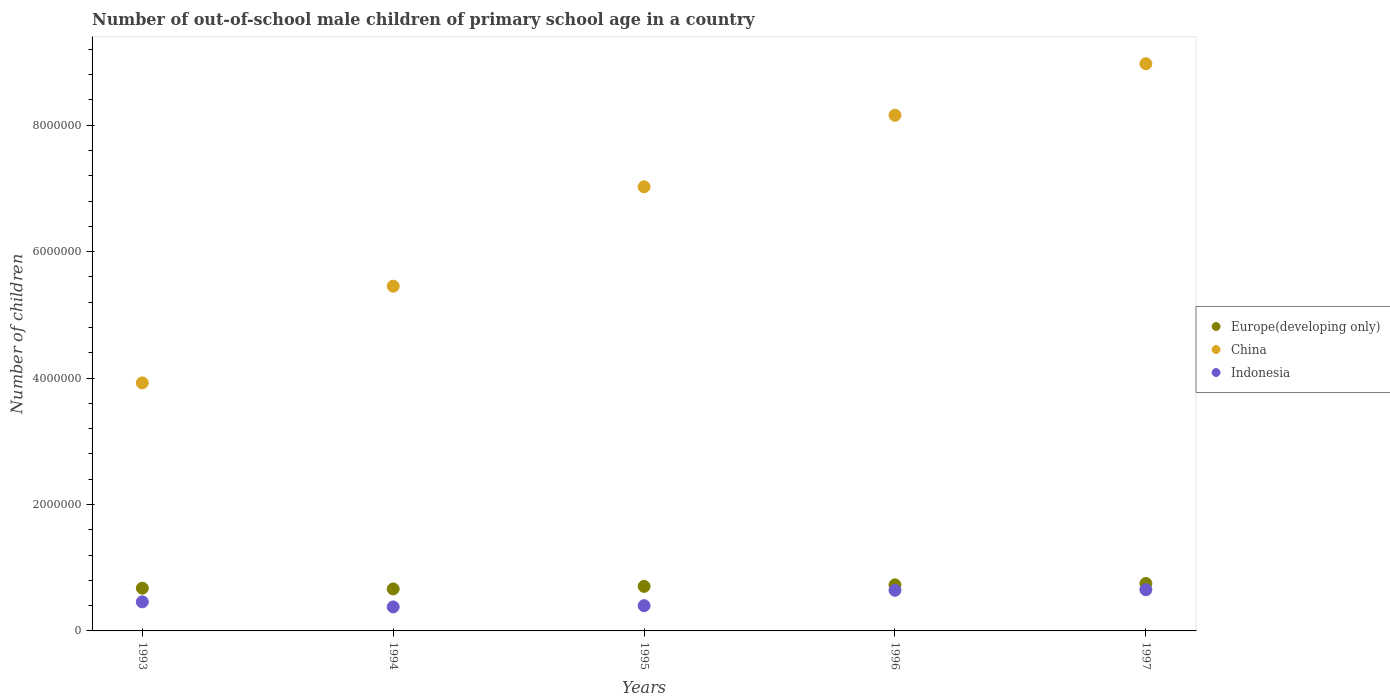How many different coloured dotlines are there?
Your response must be concise. 3. What is the number of out-of-school male children in Indonesia in 1996?
Your response must be concise. 6.43e+05. Across all years, what is the maximum number of out-of-school male children in Europe(developing only)?
Provide a succinct answer. 7.51e+05. Across all years, what is the minimum number of out-of-school male children in Indonesia?
Your answer should be very brief. 3.79e+05. In which year was the number of out-of-school male children in China minimum?
Your answer should be compact. 1993. What is the total number of out-of-school male children in Europe(developing only) in the graph?
Keep it short and to the point. 3.52e+06. What is the difference between the number of out-of-school male children in Europe(developing only) in 1993 and that in 1997?
Provide a short and direct response. -7.45e+04. What is the difference between the number of out-of-school male children in Indonesia in 1995 and the number of out-of-school male children in China in 1997?
Your answer should be very brief. -8.57e+06. What is the average number of out-of-school male children in China per year?
Keep it short and to the point. 6.71e+06. In the year 1997, what is the difference between the number of out-of-school male children in Indonesia and number of out-of-school male children in China?
Give a very brief answer. -8.32e+06. What is the ratio of the number of out-of-school male children in China in 1993 to that in 1997?
Give a very brief answer. 0.44. Is the difference between the number of out-of-school male children in Indonesia in 1995 and 1997 greater than the difference between the number of out-of-school male children in China in 1995 and 1997?
Offer a very short reply. Yes. What is the difference between the highest and the second highest number of out-of-school male children in China?
Offer a very short reply. 8.15e+05. What is the difference between the highest and the lowest number of out-of-school male children in Europe(developing only)?
Give a very brief answer. 8.62e+04. Is the sum of the number of out-of-school male children in Indonesia in 1993 and 1997 greater than the maximum number of out-of-school male children in China across all years?
Your answer should be very brief. No. Is it the case that in every year, the sum of the number of out-of-school male children in Europe(developing only) and number of out-of-school male children in Indonesia  is greater than the number of out-of-school male children in China?
Provide a short and direct response. No. How many years are there in the graph?
Offer a terse response. 5. Are the values on the major ticks of Y-axis written in scientific E-notation?
Ensure brevity in your answer.  No. How many legend labels are there?
Your response must be concise. 3. What is the title of the graph?
Ensure brevity in your answer.  Number of out-of-school male children of primary school age in a country. What is the label or title of the Y-axis?
Provide a succinct answer. Number of children. What is the Number of children of Europe(developing only) in 1993?
Your response must be concise. 6.76e+05. What is the Number of children of China in 1993?
Offer a terse response. 3.92e+06. What is the Number of children in Indonesia in 1993?
Offer a very short reply. 4.60e+05. What is the Number of children of Europe(developing only) in 1994?
Provide a short and direct response. 6.64e+05. What is the Number of children in China in 1994?
Provide a succinct answer. 5.45e+06. What is the Number of children of Indonesia in 1994?
Your answer should be very brief. 3.79e+05. What is the Number of children of Europe(developing only) in 1995?
Give a very brief answer. 7.05e+05. What is the Number of children in China in 1995?
Give a very brief answer. 7.03e+06. What is the Number of children of Indonesia in 1995?
Make the answer very short. 4.00e+05. What is the Number of children of Europe(developing only) in 1996?
Provide a short and direct response. 7.29e+05. What is the Number of children in China in 1996?
Your answer should be very brief. 8.16e+06. What is the Number of children of Indonesia in 1996?
Ensure brevity in your answer.  6.43e+05. What is the Number of children in Europe(developing only) in 1997?
Your answer should be compact. 7.51e+05. What is the Number of children in China in 1997?
Provide a succinct answer. 8.97e+06. What is the Number of children in Indonesia in 1997?
Ensure brevity in your answer.  6.51e+05. Across all years, what is the maximum Number of children of Europe(developing only)?
Your answer should be very brief. 7.51e+05. Across all years, what is the maximum Number of children in China?
Ensure brevity in your answer.  8.97e+06. Across all years, what is the maximum Number of children of Indonesia?
Provide a short and direct response. 6.51e+05. Across all years, what is the minimum Number of children in Europe(developing only)?
Your answer should be compact. 6.64e+05. Across all years, what is the minimum Number of children of China?
Ensure brevity in your answer.  3.92e+06. Across all years, what is the minimum Number of children of Indonesia?
Your answer should be very brief. 3.79e+05. What is the total Number of children in Europe(developing only) in the graph?
Keep it short and to the point. 3.52e+06. What is the total Number of children of China in the graph?
Your answer should be very brief. 3.35e+07. What is the total Number of children of Indonesia in the graph?
Ensure brevity in your answer.  2.53e+06. What is the difference between the Number of children in Europe(developing only) in 1993 and that in 1994?
Make the answer very short. 1.17e+04. What is the difference between the Number of children in China in 1993 and that in 1994?
Provide a succinct answer. -1.53e+06. What is the difference between the Number of children in Indonesia in 1993 and that in 1994?
Give a very brief answer. 8.03e+04. What is the difference between the Number of children in Europe(developing only) in 1993 and that in 1995?
Ensure brevity in your answer.  -2.86e+04. What is the difference between the Number of children in China in 1993 and that in 1995?
Provide a succinct answer. -3.10e+06. What is the difference between the Number of children of Indonesia in 1993 and that in 1995?
Give a very brief answer. 6.02e+04. What is the difference between the Number of children in Europe(developing only) in 1993 and that in 1996?
Provide a succinct answer. -5.28e+04. What is the difference between the Number of children of China in 1993 and that in 1996?
Your answer should be very brief. -4.23e+06. What is the difference between the Number of children of Indonesia in 1993 and that in 1996?
Provide a short and direct response. -1.83e+05. What is the difference between the Number of children of Europe(developing only) in 1993 and that in 1997?
Your answer should be compact. -7.45e+04. What is the difference between the Number of children of China in 1993 and that in 1997?
Offer a very short reply. -5.05e+06. What is the difference between the Number of children of Indonesia in 1993 and that in 1997?
Your response must be concise. -1.92e+05. What is the difference between the Number of children of Europe(developing only) in 1994 and that in 1995?
Your answer should be compact. -4.03e+04. What is the difference between the Number of children of China in 1994 and that in 1995?
Offer a terse response. -1.57e+06. What is the difference between the Number of children in Indonesia in 1994 and that in 1995?
Provide a succinct answer. -2.02e+04. What is the difference between the Number of children in Europe(developing only) in 1994 and that in 1996?
Offer a terse response. -6.45e+04. What is the difference between the Number of children in China in 1994 and that in 1996?
Keep it short and to the point. -2.70e+06. What is the difference between the Number of children of Indonesia in 1994 and that in 1996?
Ensure brevity in your answer.  -2.64e+05. What is the difference between the Number of children in Europe(developing only) in 1994 and that in 1997?
Offer a very short reply. -8.62e+04. What is the difference between the Number of children of China in 1994 and that in 1997?
Offer a terse response. -3.52e+06. What is the difference between the Number of children in Indonesia in 1994 and that in 1997?
Keep it short and to the point. -2.72e+05. What is the difference between the Number of children in Europe(developing only) in 1995 and that in 1996?
Your answer should be compact. -2.42e+04. What is the difference between the Number of children in China in 1995 and that in 1996?
Your answer should be very brief. -1.13e+06. What is the difference between the Number of children of Indonesia in 1995 and that in 1996?
Offer a terse response. -2.43e+05. What is the difference between the Number of children of Europe(developing only) in 1995 and that in 1997?
Ensure brevity in your answer.  -4.59e+04. What is the difference between the Number of children in China in 1995 and that in 1997?
Provide a short and direct response. -1.95e+06. What is the difference between the Number of children of Indonesia in 1995 and that in 1997?
Offer a very short reply. -2.52e+05. What is the difference between the Number of children of Europe(developing only) in 1996 and that in 1997?
Keep it short and to the point. -2.17e+04. What is the difference between the Number of children of China in 1996 and that in 1997?
Offer a very short reply. -8.15e+05. What is the difference between the Number of children of Indonesia in 1996 and that in 1997?
Your response must be concise. -8521. What is the difference between the Number of children of Europe(developing only) in 1993 and the Number of children of China in 1994?
Your answer should be compact. -4.78e+06. What is the difference between the Number of children of Europe(developing only) in 1993 and the Number of children of Indonesia in 1994?
Keep it short and to the point. 2.97e+05. What is the difference between the Number of children of China in 1993 and the Number of children of Indonesia in 1994?
Offer a terse response. 3.54e+06. What is the difference between the Number of children in Europe(developing only) in 1993 and the Number of children in China in 1995?
Keep it short and to the point. -6.35e+06. What is the difference between the Number of children of Europe(developing only) in 1993 and the Number of children of Indonesia in 1995?
Keep it short and to the point. 2.76e+05. What is the difference between the Number of children in China in 1993 and the Number of children in Indonesia in 1995?
Your response must be concise. 3.52e+06. What is the difference between the Number of children of Europe(developing only) in 1993 and the Number of children of China in 1996?
Make the answer very short. -7.48e+06. What is the difference between the Number of children of Europe(developing only) in 1993 and the Number of children of Indonesia in 1996?
Offer a terse response. 3.31e+04. What is the difference between the Number of children in China in 1993 and the Number of children in Indonesia in 1996?
Make the answer very short. 3.28e+06. What is the difference between the Number of children of Europe(developing only) in 1993 and the Number of children of China in 1997?
Keep it short and to the point. -8.30e+06. What is the difference between the Number of children in Europe(developing only) in 1993 and the Number of children in Indonesia in 1997?
Provide a short and direct response. 2.46e+04. What is the difference between the Number of children of China in 1993 and the Number of children of Indonesia in 1997?
Make the answer very short. 3.27e+06. What is the difference between the Number of children in Europe(developing only) in 1994 and the Number of children in China in 1995?
Your answer should be compact. -6.36e+06. What is the difference between the Number of children of Europe(developing only) in 1994 and the Number of children of Indonesia in 1995?
Your response must be concise. 2.65e+05. What is the difference between the Number of children of China in 1994 and the Number of children of Indonesia in 1995?
Offer a terse response. 5.05e+06. What is the difference between the Number of children in Europe(developing only) in 1994 and the Number of children in China in 1996?
Provide a short and direct response. -7.49e+06. What is the difference between the Number of children of Europe(developing only) in 1994 and the Number of children of Indonesia in 1996?
Your answer should be compact. 2.13e+04. What is the difference between the Number of children in China in 1994 and the Number of children in Indonesia in 1996?
Provide a short and direct response. 4.81e+06. What is the difference between the Number of children in Europe(developing only) in 1994 and the Number of children in China in 1997?
Offer a very short reply. -8.31e+06. What is the difference between the Number of children in Europe(developing only) in 1994 and the Number of children in Indonesia in 1997?
Give a very brief answer. 1.28e+04. What is the difference between the Number of children in China in 1994 and the Number of children in Indonesia in 1997?
Make the answer very short. 4.80e+06. What is the difference between the Number of children of Europe(developing only) in 1995 and the Number of children of China in 1996?
Your answer should be compact. -7.45e+06. What is the difference between the Number of children of Europe(developing only) in 1995 and the Number of children of Indonesia in 1996?
Provide a short and direct response. 6.17e+04. What is the difference between the Number of children in China in 1995 and the Number of children in Indonesia in 1996?
Offer a terse response. 6.38e+06. What is the difference between the Number of children in Europe(developing only) in 1995 and the Number of children in China in 1997?
Your answer should be very brief. -8.27e+06. What is the difference between the Number of children of Europe(developing only) in 1995 and the Number of children of Indonesia in 1997?
Offer a terse response. 5.32e+04. What is the difference between the Number of children in China in 1995 and the Number of children in Indonesia in 1997?
Your response must be concise. 6.37e+06. What is the difference between the Number of children in Europe(developing only) in 1996 and the Number of children in China in 1997?
Make the answer very short. -8.24e+06. What is the difference between the Number of children of Europe(developing only) in 1996 and the Number of children of Indonesia in 1997?
Your answer should be compact. 7.73e+04. What is the difference between the Number of children of China in 1996 and the Number of children of Indonesia in 1997?
Offer a very short reply. 7.51e+06. What is the average Number of children in Europe(developing only) per year?
Make the answer very short. 7.05e+05. What is the average Number of children of China per year?
Your answer should be compact. 6.71e+06. What is the average Number of children in Indonesia per year?
Give a very brief answer. 5.07e+05. In the year 1993, what is the difference between the Number of children in Europe(developing only) and Number of children in China?
Ensure brevity in your answer.  -3.25e+06. In the year 1993, what is the difference between the Number of children in Europe(developing only) and Number of children in Indonesia?
Provide a succinct answer. 2.16e+05. In the year 1993, what is the difference between the Number of children in China and Number of children in Indonesia?
Your answer should be very brief. 3.46e+06. In the year 1994, what is the difference between the Number of children of Europe(developing only) and Number of children of China?
Provide a short and direct response. -4.79e+06. In the year 1994, what is the difference between the Number of children in Europe(developing only) and Number of children in Indonesia?
Offer a terse response. 2.85e+05. In the year 1994, what is the difference between the Number of children in China and Number of children in Indonesia?
Give a very brief answer. 5.07e+06. In the year 1995, what is the difference between the Number of children in Europe(developing only) and Number of children in China?
Offer a very short reply. -6.32e+06. In the year 1995, what is the difference between the Number of children of Europe(developing only) and Number of children of Indonesia?
Your response must be concise. 3.05e+05. In the year 1995, what is the difference between the Number of children in China and Number of children in Indonesia?
Offer a very short reply. 6.63e+06. In the year 1996, what is the difference between the Number of children in Europe(developing only) and Number of children in China?
Ensure brevity in your answer.  -7.43e+06. In the year 1996, what is the difference between the Number of children in Europe(developing only) and Number of children in Indonesia?
Offer a very short reply. 8.58e+04. In the year 1996, what is the difference between the Number of children in China and Number of children in Indonesia?
Give a very brief answer. 7.51e+06. In the year 1997, what is the difference between the Number of children in Europe(developing only) and Number of children in China?
Ensure brevity in your answer.  -8.22e+06. In the year 1997, what is the difference between the Number of children of Europe(developing only) and Number of children of Indonesia?
Your answer should be compact. 9.90e+04. In the year 1997, what is the difference between the Number of children of China and Number of children of Indonesia?
Offer a very short reply. 8.32e+06. What is the ratio of the Number of children in Europe(developing only) in 1993 to that in 1994?
Your answer should be very brief. 1.02. What is the ratio of the Number of children in China in 1993 to that in 1994?
Offer a terse response. 0.72. What is the ratio of the Number of children of Indonesia in 1993 to that in 1994?
Your response must be concise. 1.21. What is the ratio of the Number of children of Europe(developing only) in 1993 to that in 1995?
Your answer should be compact. 0.96. What is the ratio of the Number of children of China in 1993 to that in 1995?
Offer a terse response. 0.56. What is the ratio of the Number of children of Indonesia in 1993 to that in 1995?
Give a very brief answer. 1.15. What is the ratio of the Number of children of Europe(developing only) in 1993 to that in 1996?
Keep it short and to the point. 0.93. What is the ratio of the Number of children of China in 1993 to that in 1996?
Ensure brevity in your answer.  0.48. What is the ratio of the Number of children of Indonesia in 1993 to that in 1996?
Offer a very short reply. 0.72. What is the ratio of the Number of children of Europe(developing only) in 1993 to that in 1997?
Keep it short and to the point. 0.9. What is the ratio of the Number of children in China in 1993 to that in 1997?
Keep it short and to the point. 0.44. What is the ratio of the Number of children in Indonesia in 1993 to that in 1997?
Ensure brevity in your answer.  0.71. What is the ratio of the Number of children of Europe(developing only) in 1994 to that in 1995?
Keep it short and to the point. 0.94. What is the ratio of the Number of children of China in 1994 to that in 1995?
Make the answer very short. 0.78. What is the ratio of the Number of children in Indonesia in 1994 to that in 1995?
Give a very brief answer. 0.95. What is the ratio of the Number of children of Europe(developing only) in 1994 to that in 1996?
Your answer should be compact. 0.91. What is the ratio of the Number of children in China in 1994 to that in 1996?
Offer a very short reply. 0.67. What is the ratio of the Number of children of Indonesia in 1994 to that in 1996?
Offer a terse response. 0.59. What is the ratio of the Number of children in Europe(developing only) in 1994 to that in 1997?
Your answer should be very brief. 0.89. What is the ratio of the Number of children in China in 1994 to that in 1997?
Your answer should be compact. 0.61. What is the ratio of the Number of children of Indonesia in 1994 to that in 1997?
Give a very brief answer. 0.58. What is the ratio of the Number of children in Europe(developing only) in 1995 to that in 1996?
Provide a succinct answer. 0.97. What is the ratio of the Number of children of China in 1995 to that in 1996?
Your response must be concise. 0.86. What is the ratio of the Number of children of Indonesia in 1995 to that in 1996?
Your response must be concise. 0.62. What is the ratio of the Number of children of Europe(developing only) in 1995 to that in 1997?
Your response must be concise. 0.94. What is the ratio of the Number of children of China in 1995 to that in 1997?
Offer a very short reply. 0.78. What is the ratio of the Number of children in Indonesia in 1995 to that in 1997?
Keep it short and to the point. 0.61. What is the ratio of the Number of children of Europe(developing only) in 1996 to that in 1997?
Give a very brief answer. 0.97. What is the ratio of the Number of children in China in 1996 to that in 1997?
Give a very brief answer. 0.91. What is the ratio of the Number of children of Indonesia in 1996 to that in 1997?
Provide a succinct answer. 0.99. What is the difference between the highest and the second highest Number of children of Europe(developing only)?
Your answer should be very brief. 2.17e+04. What is the difference between the highest and the second highest Number of children in China?
Ensure brevity in your answer.  8.15e+05. What is the difference between the highest and the second highest Number of children in Indonesia?
Make the answer very short. 8521. What is the difference between the highest and the lowest Number of children in Europe(developing only)?
Keep it short and to the point. 8.62e+04. What is the difference between the highest and the lowest Number of children in China?
Your answer should be very brief. 5.05e+06. What is the difference between the highest and the lowest Number of children in Indonesia?
Give a very brief answer. 2.72e+05. 